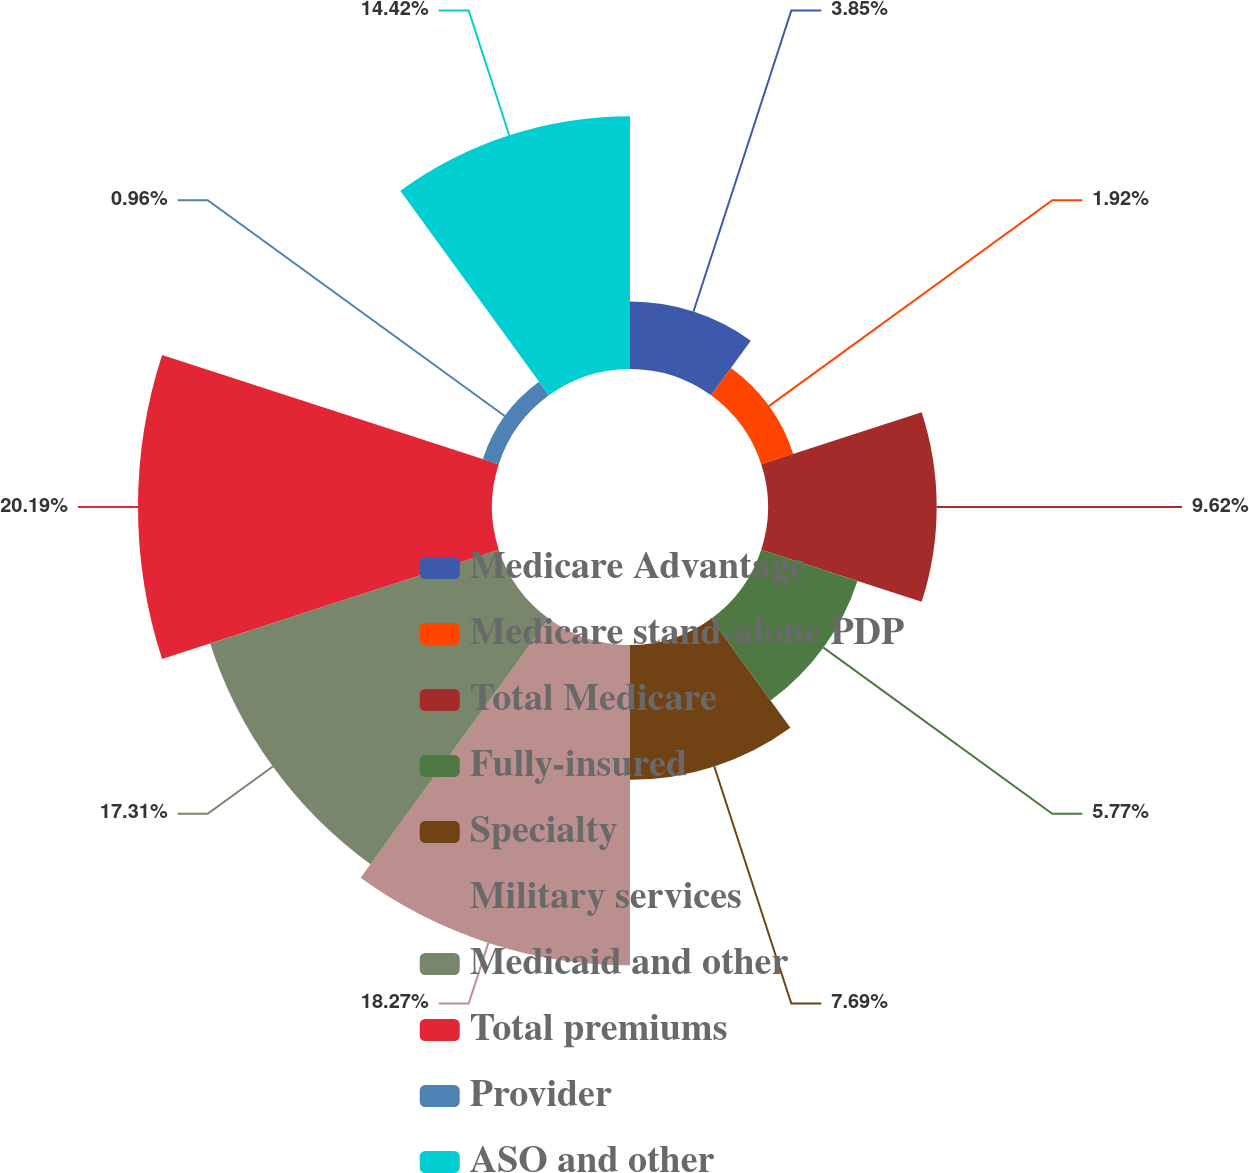<chart> <loc_0><loc_0><loc_500><loc_500><pie_chart><fcel>Medicare Advantage<fcel>Medicare stand-alone PDP<fcel>Total Medicare<fcel>Fully-insured<fcel>Specialty<fcel>Military services<fcel>Medicaid and other<fcel>Total premiums<fcel>Provider<fcel>ASO and other<nl><fcel>3.85%<fcel>1.92%<fcel>9.62%<fcel>5.77%<fcel>7.69%<fcel>18.27%<fcel>17.31%<fcel>20.19%<fcel>0.96%<fcel>14.42%<nl></chart> 